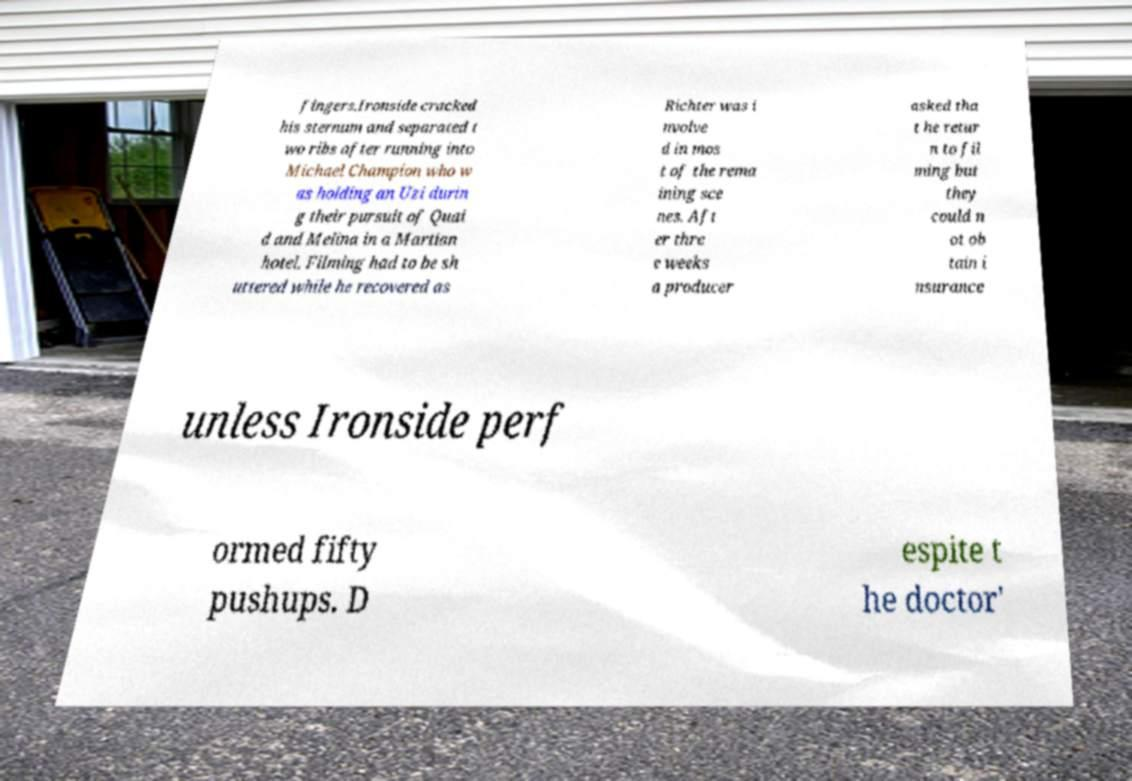For documentation purposes, I need the text within this image transcribed. Could you provide that? fingers.Ironside cracked his sternum and separated t wo ribs after running into Michael Champion who w as holding an Uzi durin g their pursuit of Quai d and Melina in a Martian hotel. Filming had to be sh uttered while he recovered as Richter was i nvolve d in mos t of the rema ining sce nes. Aft er thre e weeks a producer asked tha t he retur n to fil ming but they could n ot ob tain i nsurance unless Ironside perf ormed fifty pushups. D espite t he doctor' 